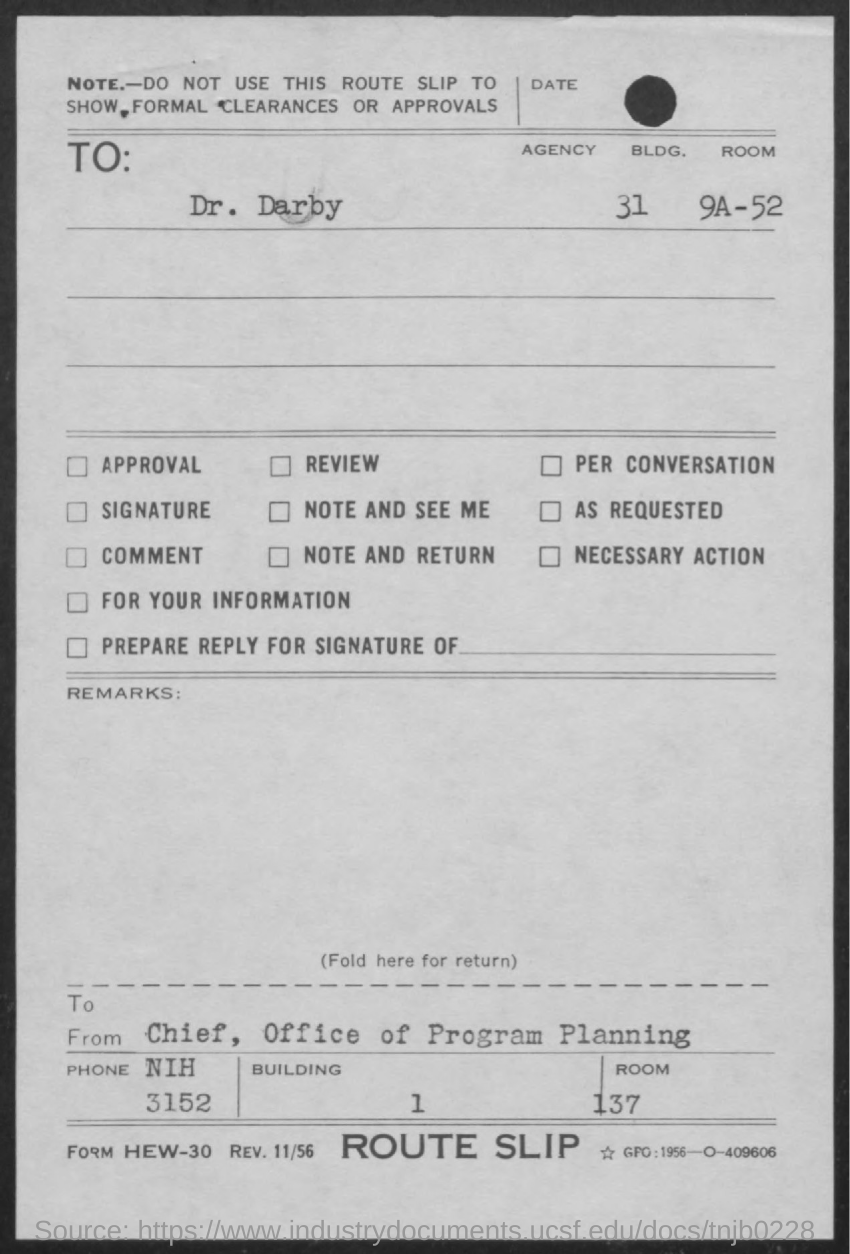To Whom is this letter addressed to?
Offer a very short reply. Dr. Darby. Who is this letter from?
Your answer should be very brief. Chief, Office of Program Planning. 